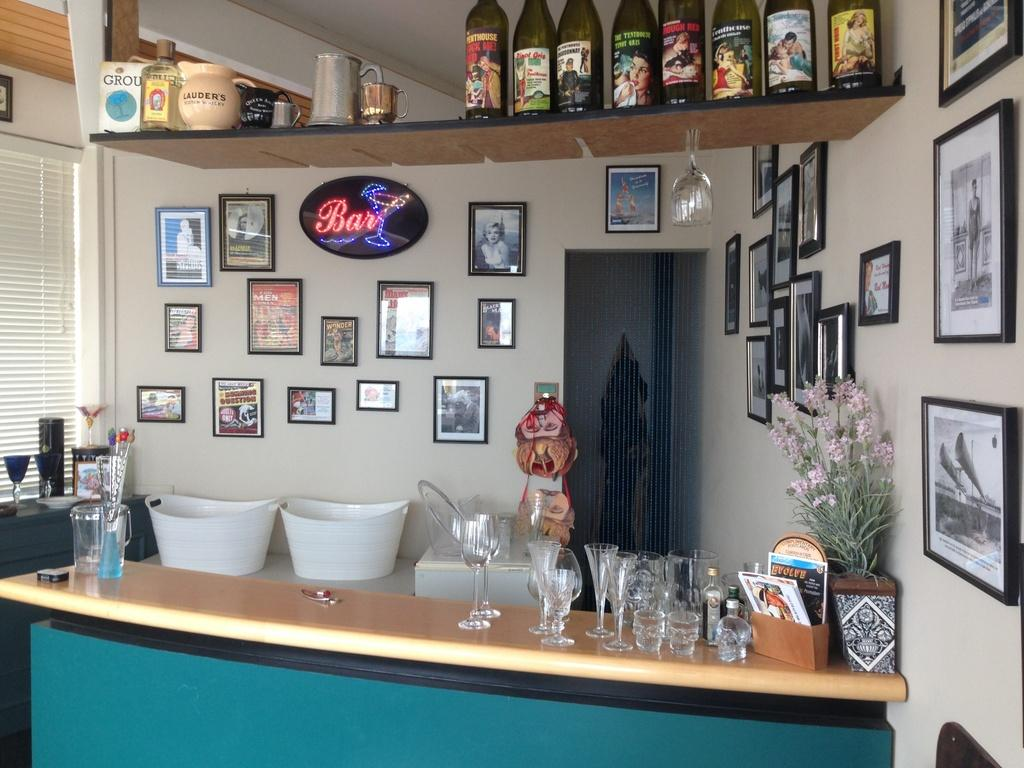<image>
Present a compact description of the photo's key features. A neon sign that say's bar on it hangs on a wall with other pictures. 